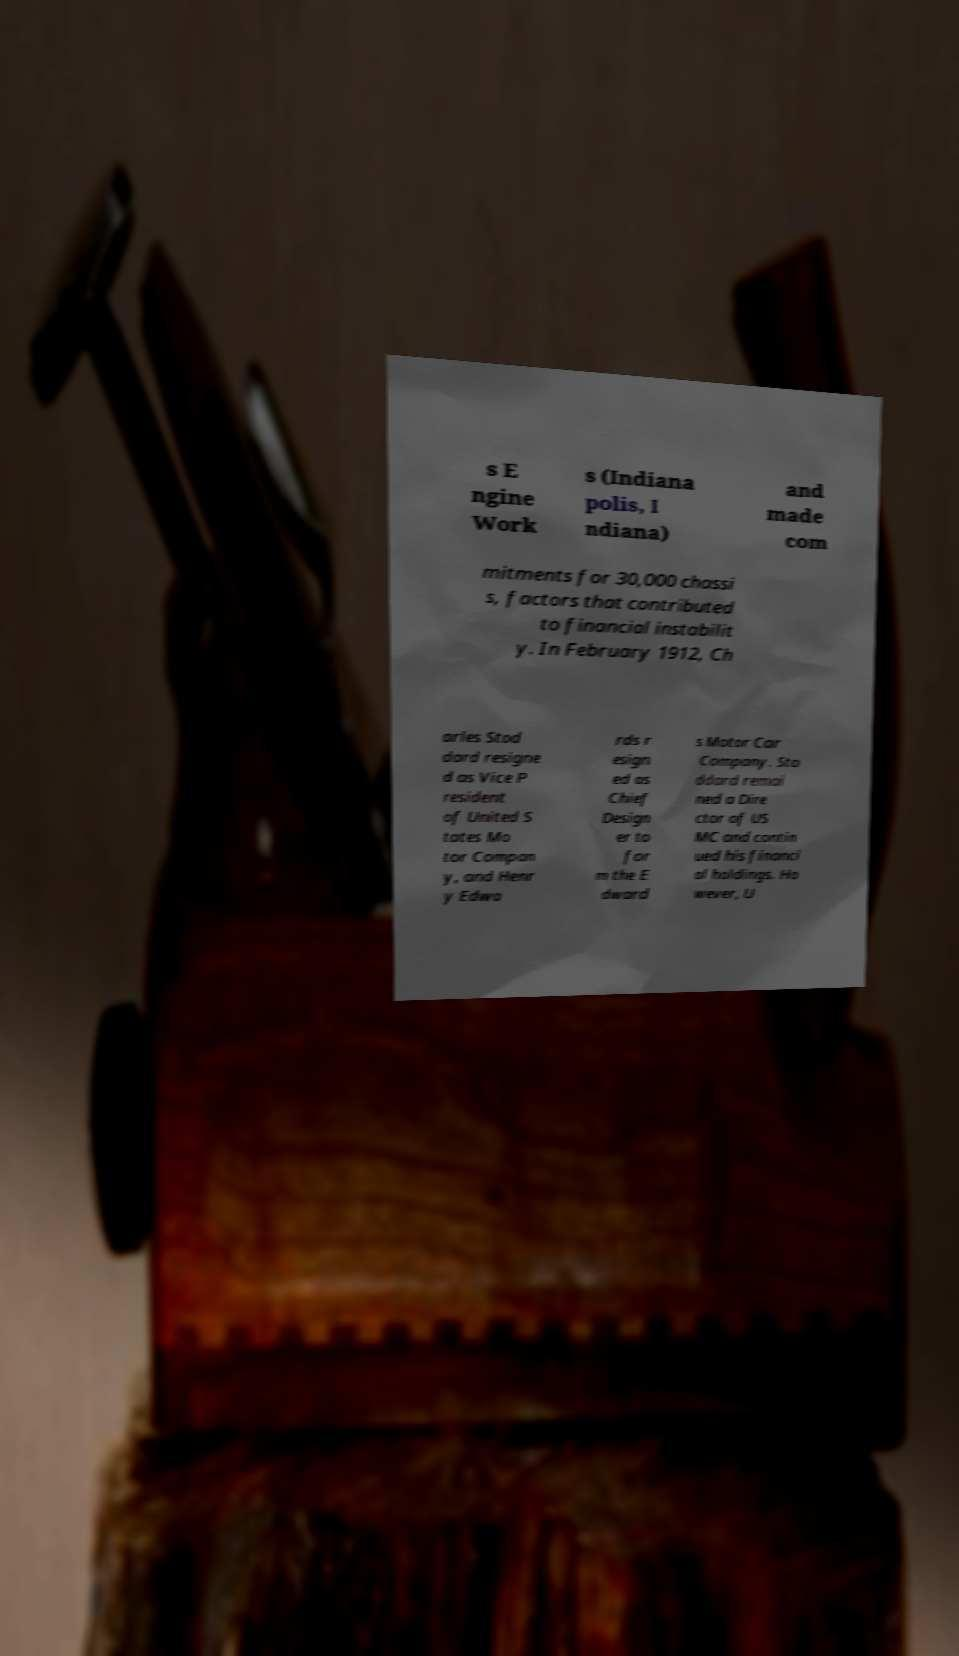Can you accurately transcribe the text from the provided image for me? s E ngine Work s (Indiana polis, I ndiana) and made com mitments for 30,000 chassi s, factors that contributed to financial instabilit y. In February 1912, Ch arles Stod dard resigne d as Vice P resident of United S tates Mo tor Compan y, and Henr y Edwa rds r esign ed as Chief Design er to for m the E dward s Motor Car Company. Sto ddard remai ned a Dire ctor of US MC and contin ued his financi al holdings. Ho wever, U 